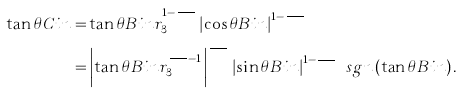Convert formula to latex. <formula><loc_0><loc_0><loc_500><loc_500>\tan \theta C i n = & \tan \theta B i n r _ { 3 } ^ { 1 - \frac { \delta B x } { \delta B y } } \left | \cos \theta B i n \right | ^ { 1 - \frac { \delta B x } { \delta B y } } \\ = & \left | \tan \theta B i n r _ { 3 } ^ { \frac { \delta B y } { \delta B x } - 1 } \right | ^ { \frac { \delta B x } { \delta B y } } \left | \sin \theta B i n \right | ^ { 1 - \frac { \delta B x } { \delta B y } } \ s g n \left ( \tan \theta B i n \right ) .</formula> 